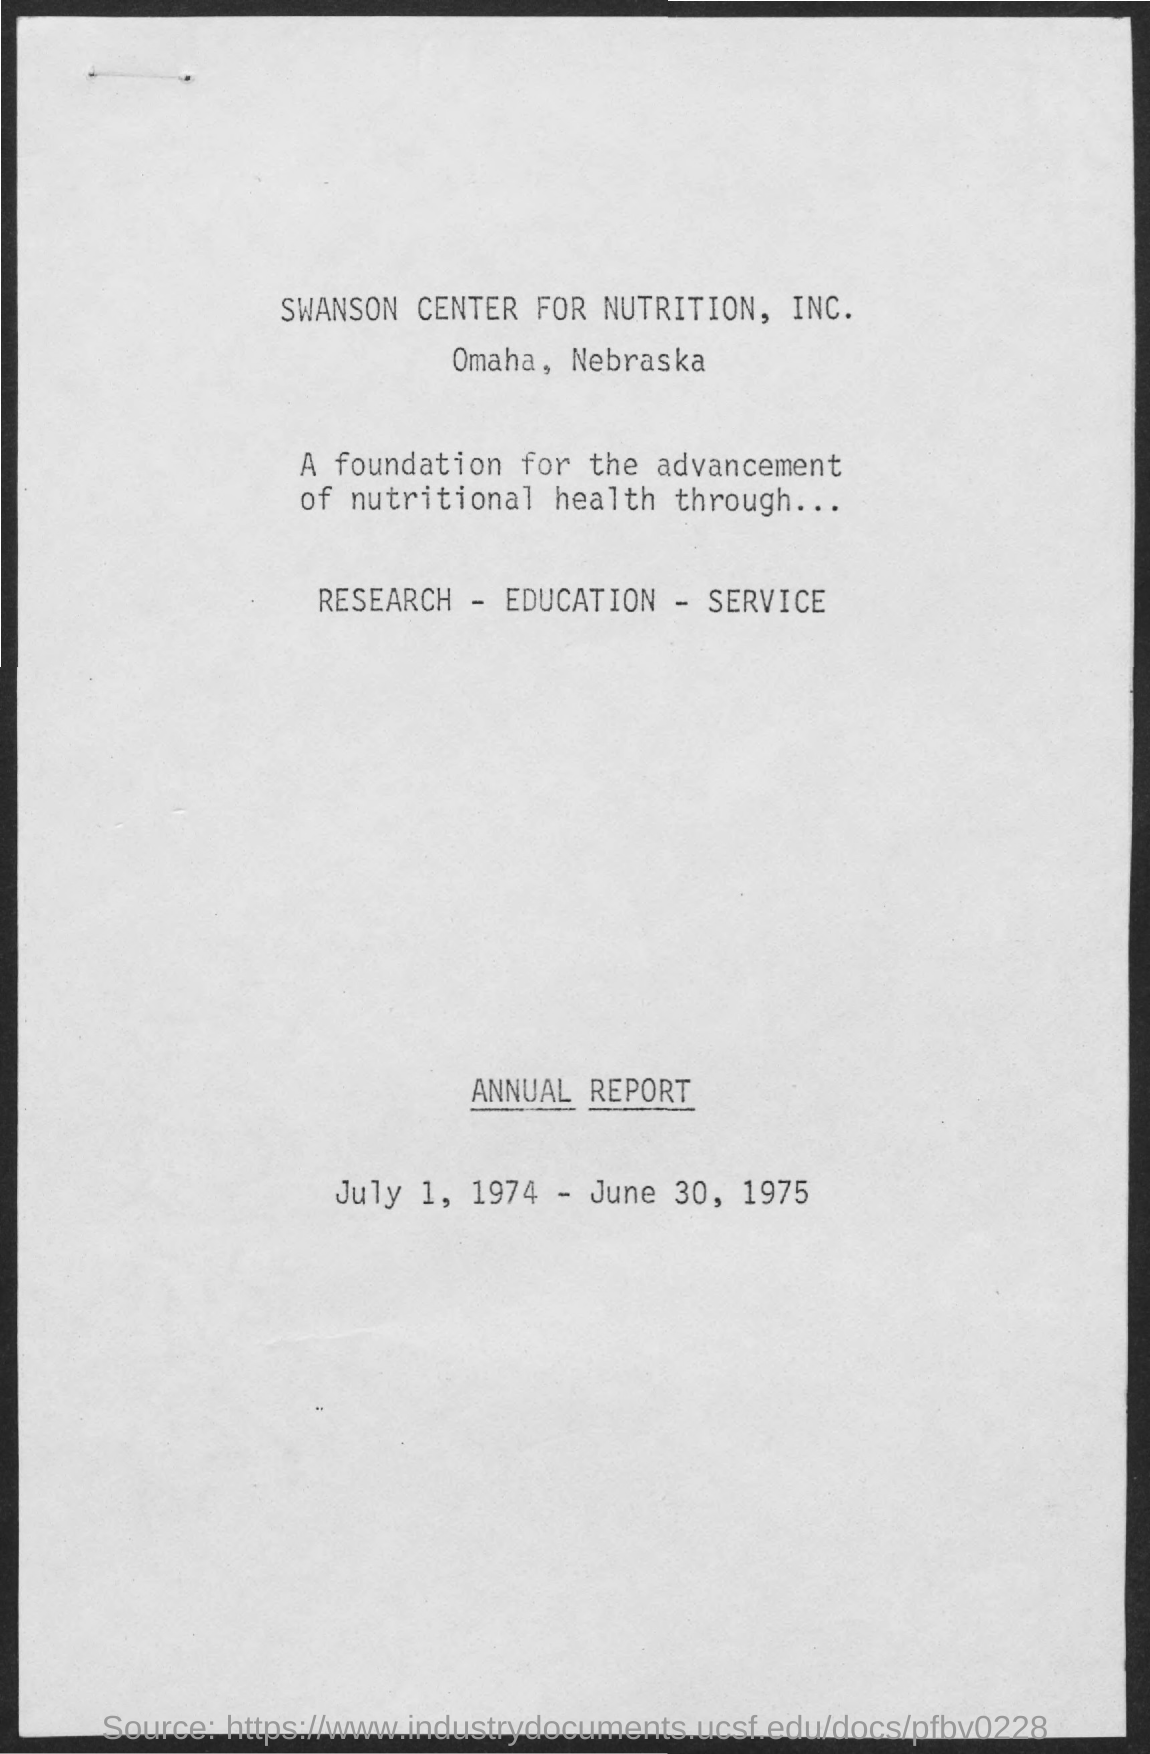What is the duration of the annual report?
Your response must be concise. July 1, 1974 - June 30, 1975. What is the location for Swanson Center for Nutrition, Inc.?
Give a very brief answer. Omaha, Nebraska. 